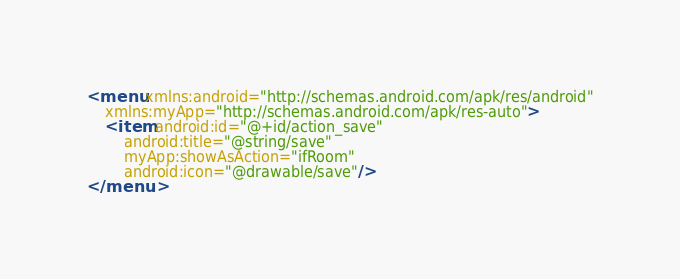Convert code to text. <code><loc_0><loc_0><loc_500><loc_500><_XML_><menu xmlns:android="http://schemas.android.com/apk/res/android"
    xmlns:myApp="http://schemas.android.com/apk/res-auto">
    <item android:id="@+id/action_save"
        android:title="@string/save"
        myApp:showAsAction="ifRoom"
        android:icon="@drawable/save"/>
</menu>
</code> 